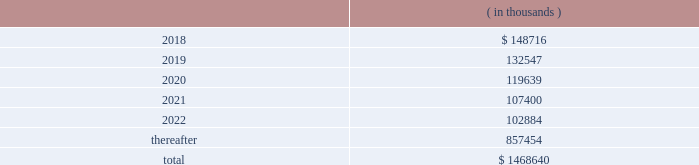Hollyfrontier corporation notes to consolidated financial statements continued .
Transportation and storage costs incurred under these agreements totaled $ 140.5 million , $ 135.1 million and $ 137.7 million for the years ended december 31 , 2017 , 2016 and 2015 , respectively .
These amounts do not include contractual commitments under our long-term transportation agreements with hep , as all transactions with hep are eliminated in these consolidated financial statements .
We have a crude oil supply contract that requires the supplier to deliver a specified volume of crude oil or pay a shortfall fee for the difference in the actual barrels delivered to us less the specified barrels per the supply contract .
For the contract year ended august 31 , 2017 , the actual number of barrels delivered to us was substantially less than the specified barrels , and we recorded a reduction to cost of goods sold and accumulated a shortfall fee receivable of $ 26.0 million during this period .
In september 2017 , the supplier notified us they are disputing the shortfall fee owed and in october 2017 notified us of their demand for arbitration .
We offset the receivable with payments of invoices for deliveries of crude oil received subsequent to august 31 , 2017 , which is permitted under the supply contract .
We believe the disputes and claims made by the supplier are without merit .
In march , 2006 , a subsidiary of ours sold the assets of montana refining company under an asset purchase agreement ( 201capa 201d ) .
Calumet montana refining llc , the current owner of the assets , has submitted requests for reimbursement of approximately $ 20.0 million pursuant to contractual indemnity provisions under the apa for various costs incurred , as well as additional claims related to environmental matters .
We have rejected most of the claims for payment , and this matter is scheduled for arbitration beginning in july 2018 .
We have accrued the costs we believe are owed pursuant to the apa , and we estimate that any reasonably possible losses beyond the amounts accrued are not material .
Note 20 : segment information effective fourth quarter of 2017 , we revised our reportable segments to align with certain changes in how our chief operating decision maker manages and allocates resources to our business .
Accordingly , our tulsa refineries 2019 lubricants operations , previously reported in the refining segment , are now combined with the operations of our petro-canada lubricants business ( acquired february 1 , 2017 ) and reported in the lubricants and specialty products segment .
Our prior period segment information has been retrospectively adjusted to reflect our current segment presentation .
Our operations are organized into three reportable segments , refining , lubricants and specialty products and hep .
Our operations that are not included in the refining , lubricants and specialty products and hep segments are included in corporate and other .
Intersegment transactions are eliminated in our consolidated financial statements and are included in eliminations .
Corporate and other and eliminations are aggregated and presented under corporate , other and eliminations column .
The refining segment represents the operations of the el dorado , tulsa , navajo , cheyenne and woods cross refineries and hfc asphalt ( aggregated as a reportable segment ) .
Refining activities involve the purchase and refining of crude oil and wholesale and branded marketing of refined products , such as gasoline , diesel fuel and jet fuel .
These petroleum products are primarily marketed in the mid-continent , southwest and rocky mountain regions of the united states .
Hfc asphalt operates various asphalt terminals in arizona , new mexico and oklahoma. .
What percentage of total costs occurred after 2022? 
Computations: (857454 / 1468640)
Answer: 0.58384. 